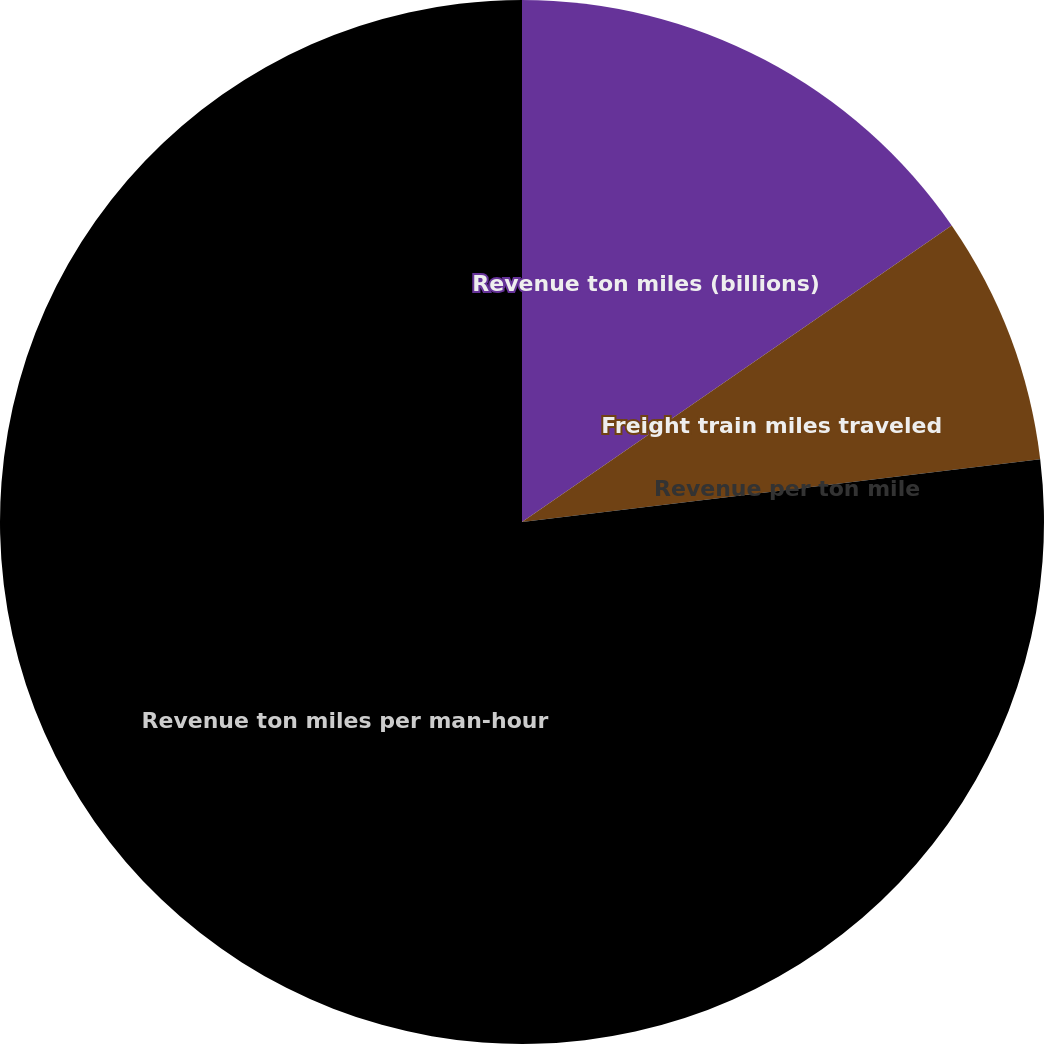<chart> <loc_0><loc_0><loc_500><loc_500><pie_chart><fcel>Revenue ton miles (billions)<fcel>Freight train miles traveled<fcel>Revenue per ton mile<fcel>Revenue ton miles per man-hour<nl><fcel>15.39%<fcel>7.69%<fcel>0.0%<fcel>76.92%<nl></chart> 